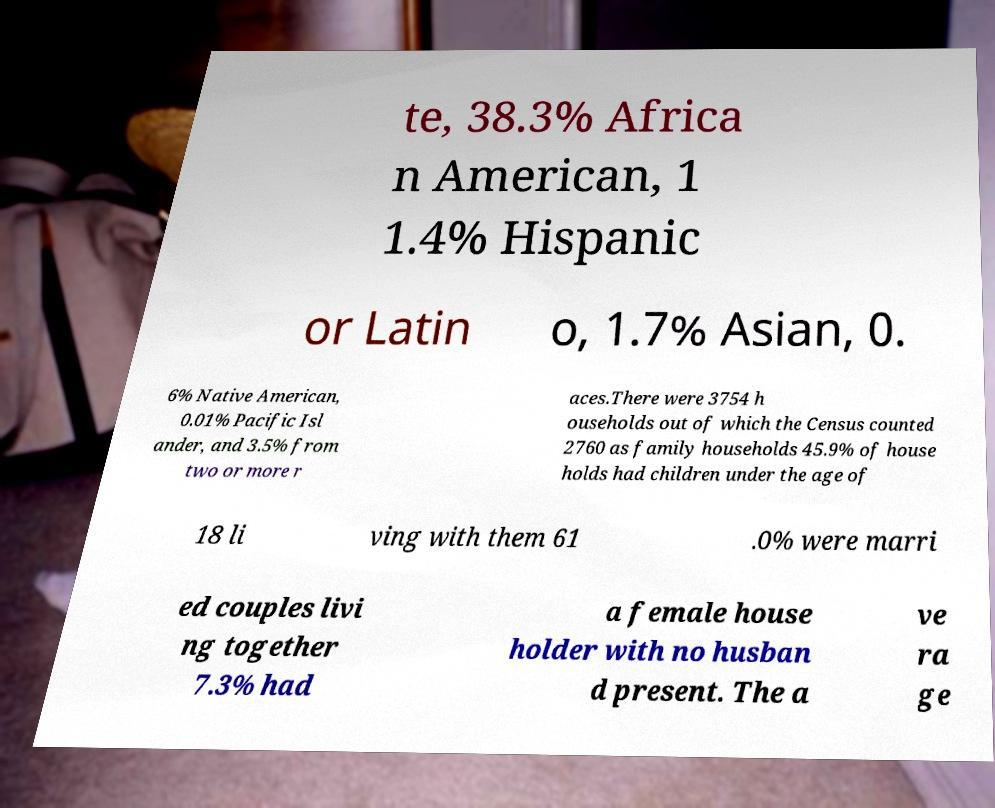What messages or text are displayed in this image? I need them in a readable, typed format. te, 38.3% Africa n American, 1 1.4% Hispanic or Latin o, 1.7% Asian, 0. 6% Native American, 0.01% Pacific Isl ander, and 3.5% from two or more r aces.There were 3754 h ouseholds out of which the Census counted 2760 as family households 45.9% of house holds had children under the age of 18 li ving with them 61 .0% were marri ed couples livi ng together 7.3% had a female house holder with no husban d present. The a ve ra ge 